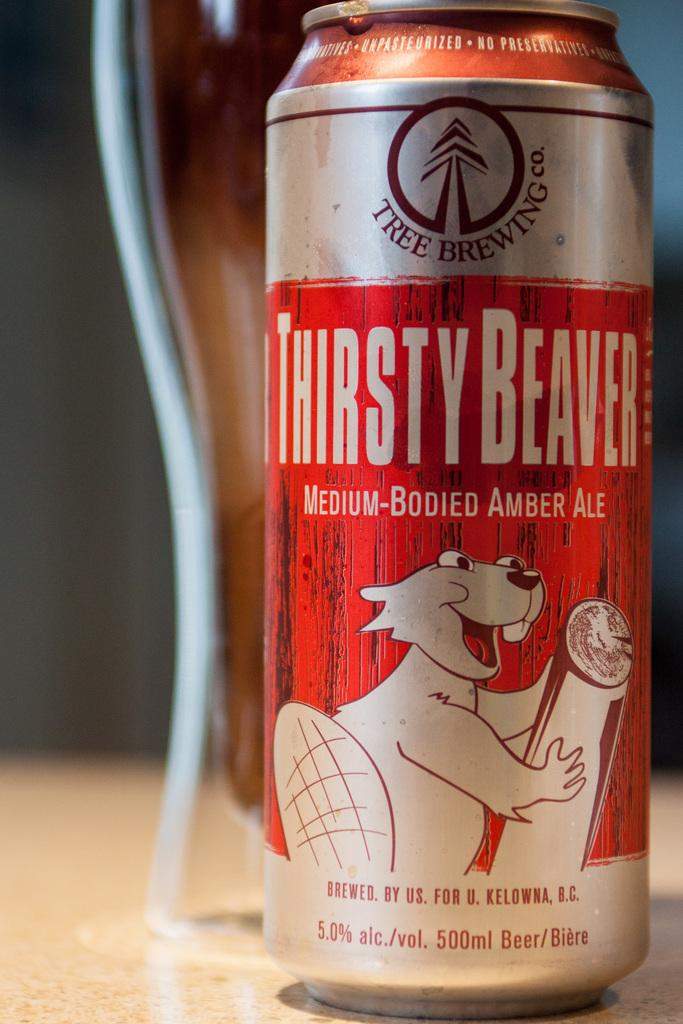<image>
Summarize the visual content of the image. A Thirsty Beaver can of Medium-Bodied Amber Ale sits in front of a glass. 